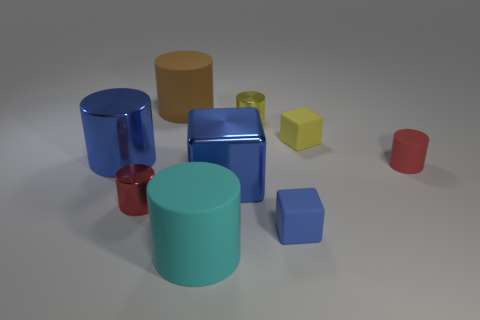How many objects are there in total, and can you distinguish them by color? In total, there are seven objects. Starting from the left, there's a red cup, a blue metallic cylinder, a cyan rubber cylinder, a blue cube, a yellow metallic cylinder, a small yellow cube, and a red cylinder. 